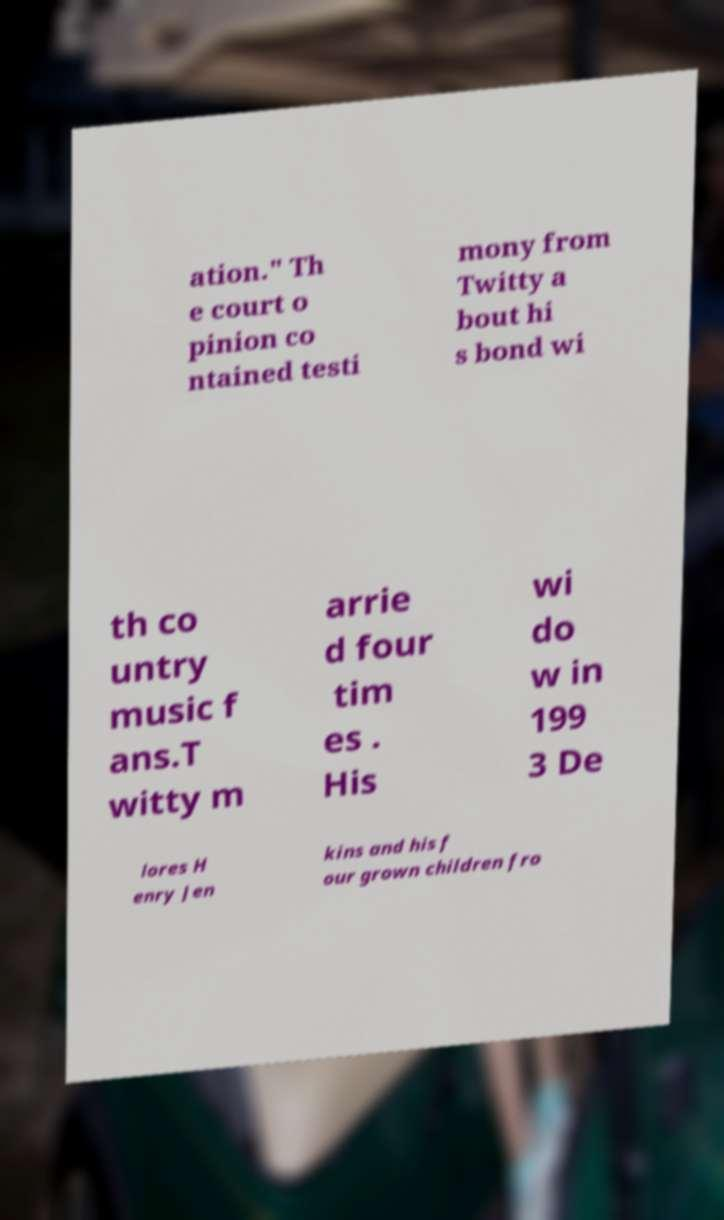Can you accurately transcribe the text from the provided image for me? ation." Th e court o pinion co ntained testi mony from Twitty a bout hi s bond wi th co untry music f ans.T witty m arrie d four tim es . His wi do w in 199 3 De lores H enry Jen kins and his f our grown children fro 